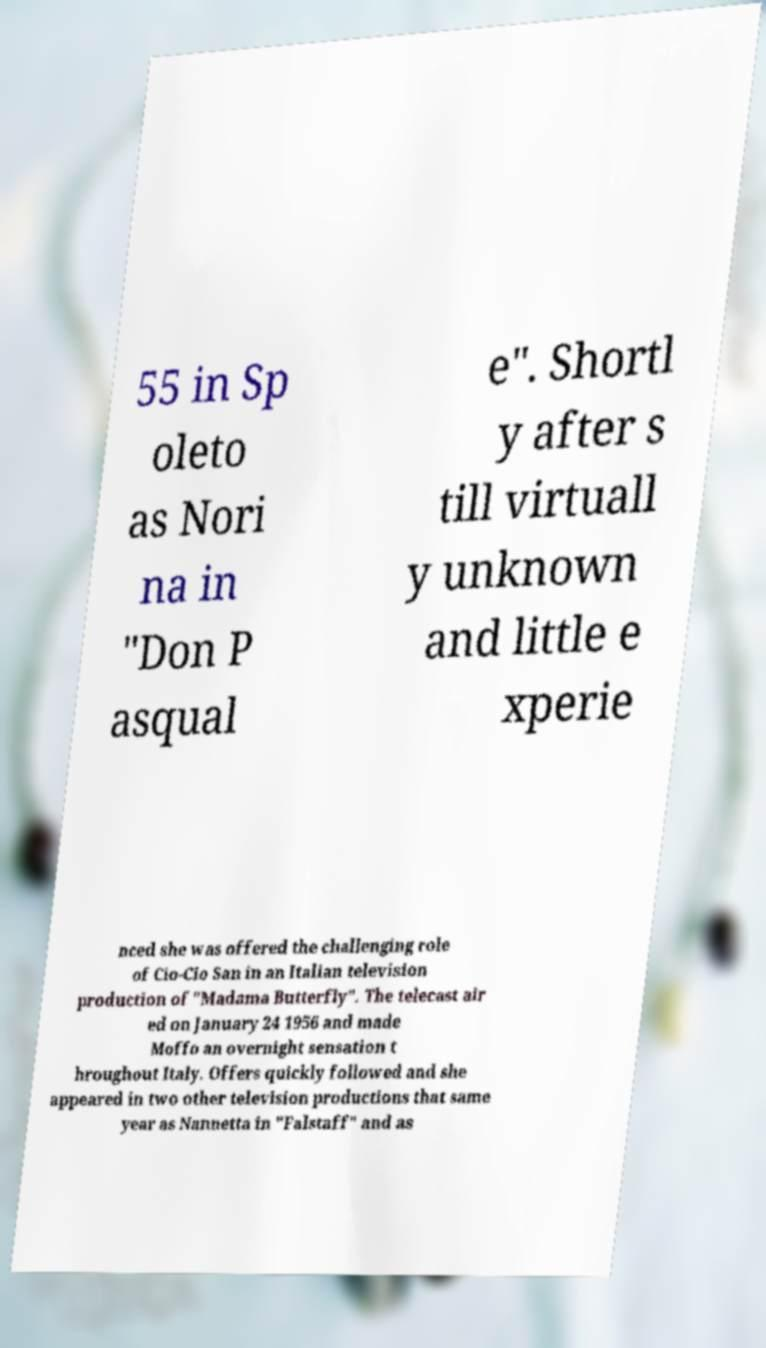What messages or text are displayed in this image? I need them in a readable, typed format. 55 in Sp oleto as Nori na in "Don P asqual e". Shortl y after s till virtuall y unknown and little e xperie nced she was offered the challenging role of Cio-Cio San in an Italian television production of "Madama Butterfly". The telecast air ed on January 24 1956 and made Moffo an overnight sensation t hroughout Italy. Offers quickly followed and she appeared in two other television productions that same year as Nannetta in "Falstaff" and as 